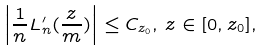Convert formula to latex. <formula><loc_0><loc_0><loc_500><loc_500>\left | \frac { 1 } { n } L ^ { \prime } _ { n } ( \frac { z } { m } ) \right | \leq C _ { z _ { 0 } } , \, z \in [ 0 , z _ { 0 } ] ,</formula> 